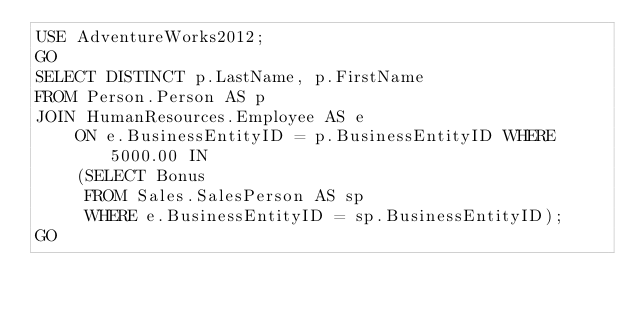<code> <loc_0><loc_0><loc_500><loc_500><_SQL_>USE AdventureWorks2012;
GO
SELECT DISTINCT p.LastName, p.FirstName 
FROM Person.Person AS p 
JOIN HumanResources.Employee AS e
    ON e.BusinessEntityID = p.BusinessEntityID WHERE 5000.00 IN
    (SELECT Bonus
     FROM Sales.SalesPerson AS sp
     WHERE e.BusinessEntityID = sp.BusinessEntityID);
GO</code> 